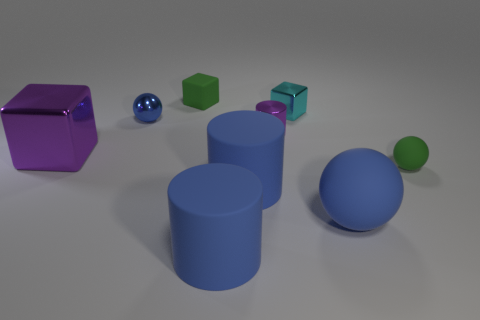Among the different objects, which ones are geometrically identical? In this image, the small cyan cube and the large purple cube are geometrically identical in shape—both are cubes. However, they differ in size and color, illustrating how objects can share the same geometry but other characteristics can vary widely. 